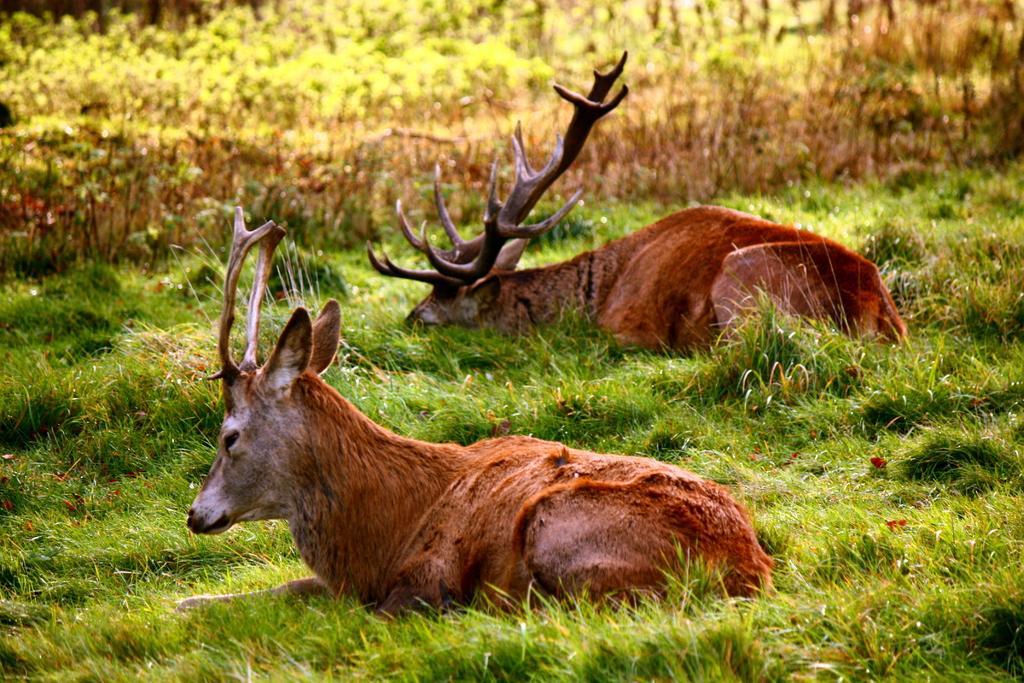In one or two sentences, can you explain what this image depicts? In this image we can see two animals are sitting on the grass on the ground. In the background we can see plants. 